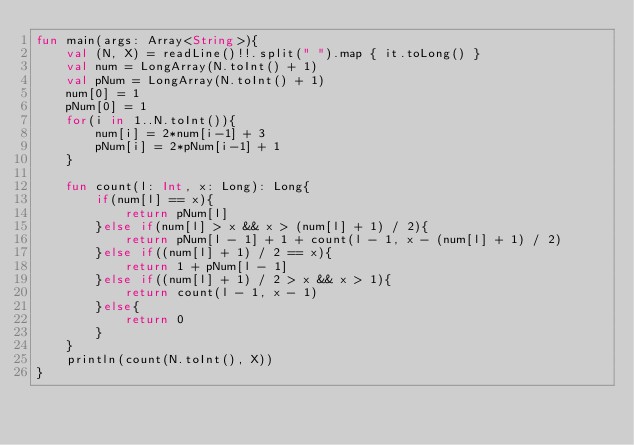<code> <loc_0><loc_0><loc_500><loc_500><_Kotlin_>fun main(args: Array<String>){
    val (N, X) = readLine()!!.split(" ").map { it.toLong() }
    val num = LongArray(N.toInt() + 1)
    val pNum = LongArray(N.toInt() + 1)
    num[0] = 1
    pNum[0] = 1
    for(i in 1..N.toInt()){
        num[i] = 2*num[i-1] + 3
        pNum[i] = 2*pNum[i-1] + 1
    }

    fun count(l: Int, x: Long): Long{
        if(num[l] == x){
            return pNum[l]
        }else if(num[l] > x && x > (num[l] + 1) / 2){
            return pNum[l - 1] + 1 + count(l - 1, x - (num[l] + 1) / 2)
        }else if((num[l] + 1) / 2 == x){
            return 1 + pNum[l - 1]
        }else if((num[l] + 1) / 2 > x && x > 1){
            return count(l - 1, x - 1)
        }else{
            return 0
        }
    }
    println(count(N.toInt(), X))
}</code> 